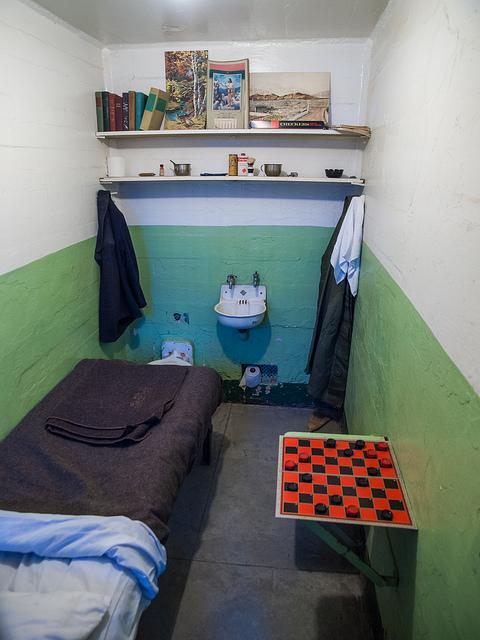Who most likely sleeps here? prisoner 